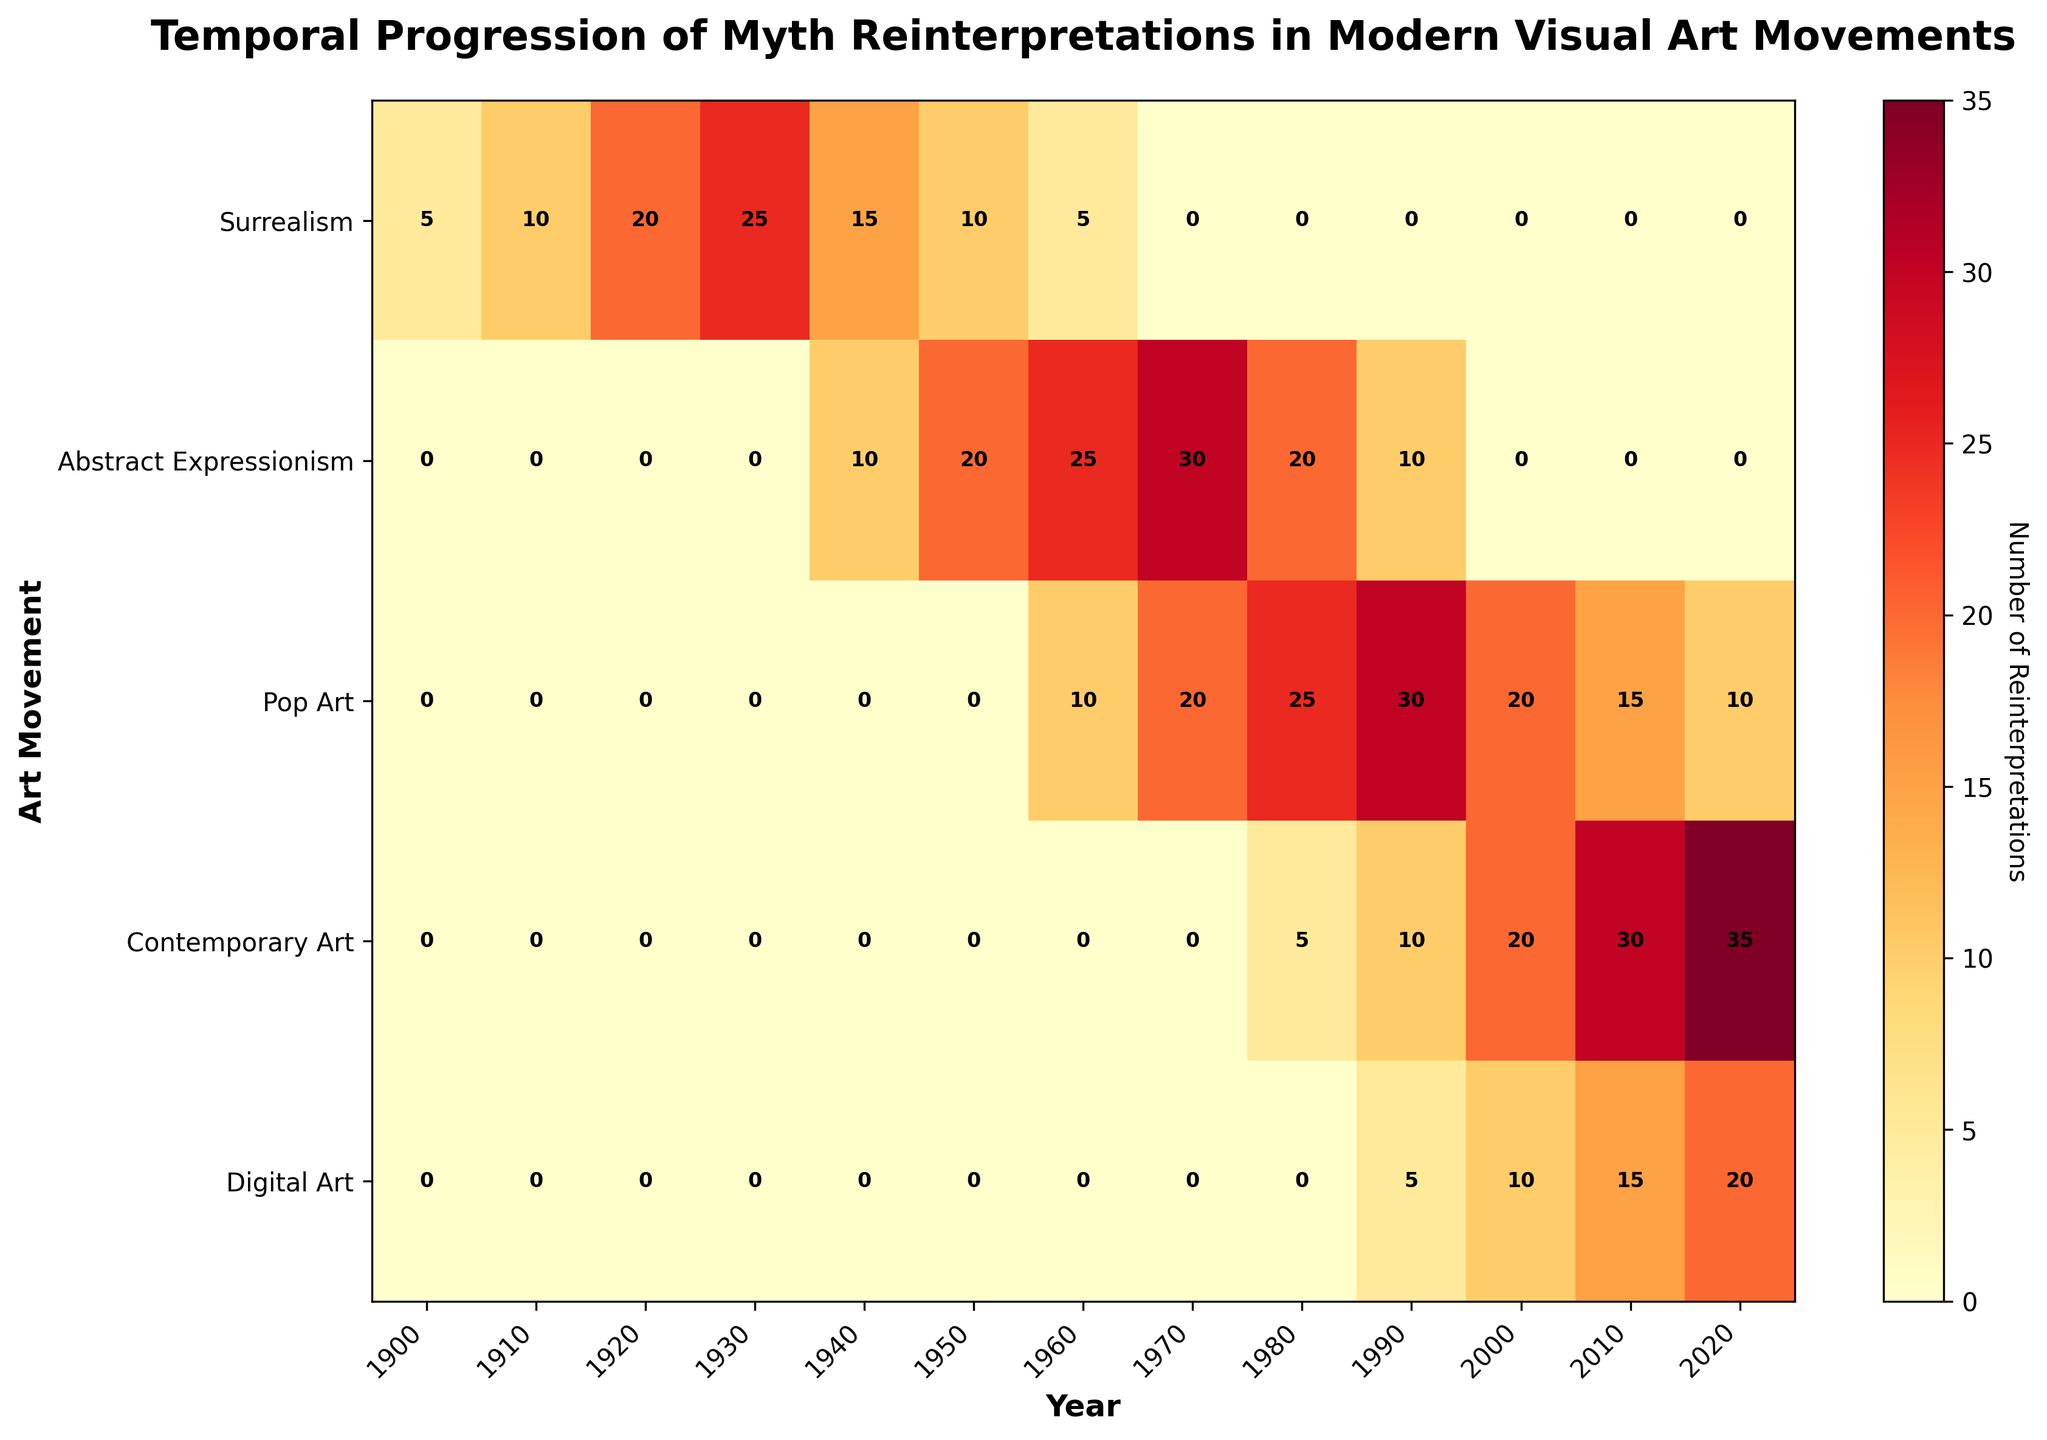What's the title of the heatmap? The title is typically displayed at the top of the heatmap in bold font.
Answer: Temporal Progression of Myth Reinterpretations in Modern Visual Art Movements What does the color bar indicate? The color bar, usually found on the side of the plot, explains the color intensity that represents numerical values of reinterpretations.
Answer: Number of Reinterpretations Which art movement shows the highest number of reinterpretations in 2000? Look at the column for the year 2000 and identify the art movement with the highest number.
Answer: Contemporary Art How does the number of reinterpretations in Surrealism change from 1900 to 1940? Observe the values for Surrealism across the years 1900, 1910, 1920, 1930, and 1940. It starts at 5 and increases to 25, then drops to 15 by 1940.
Answer: Increases till 1930, then decreases In what period did Abstract Expressionism see its peak in reinterpretations? Determine the year where Abstract Expressionism has the highest value.
Answer: 1970 During which period does Digital Art start to show reinterpretations? Check the years where the values for Digital Art start to appear.
Answer: 1990 Which art movement shows a consistent increase in reinterpretations up to 2020? Identify an art movement where values keep increasing without any drop until 2020.
Answer: Contemporary Art 